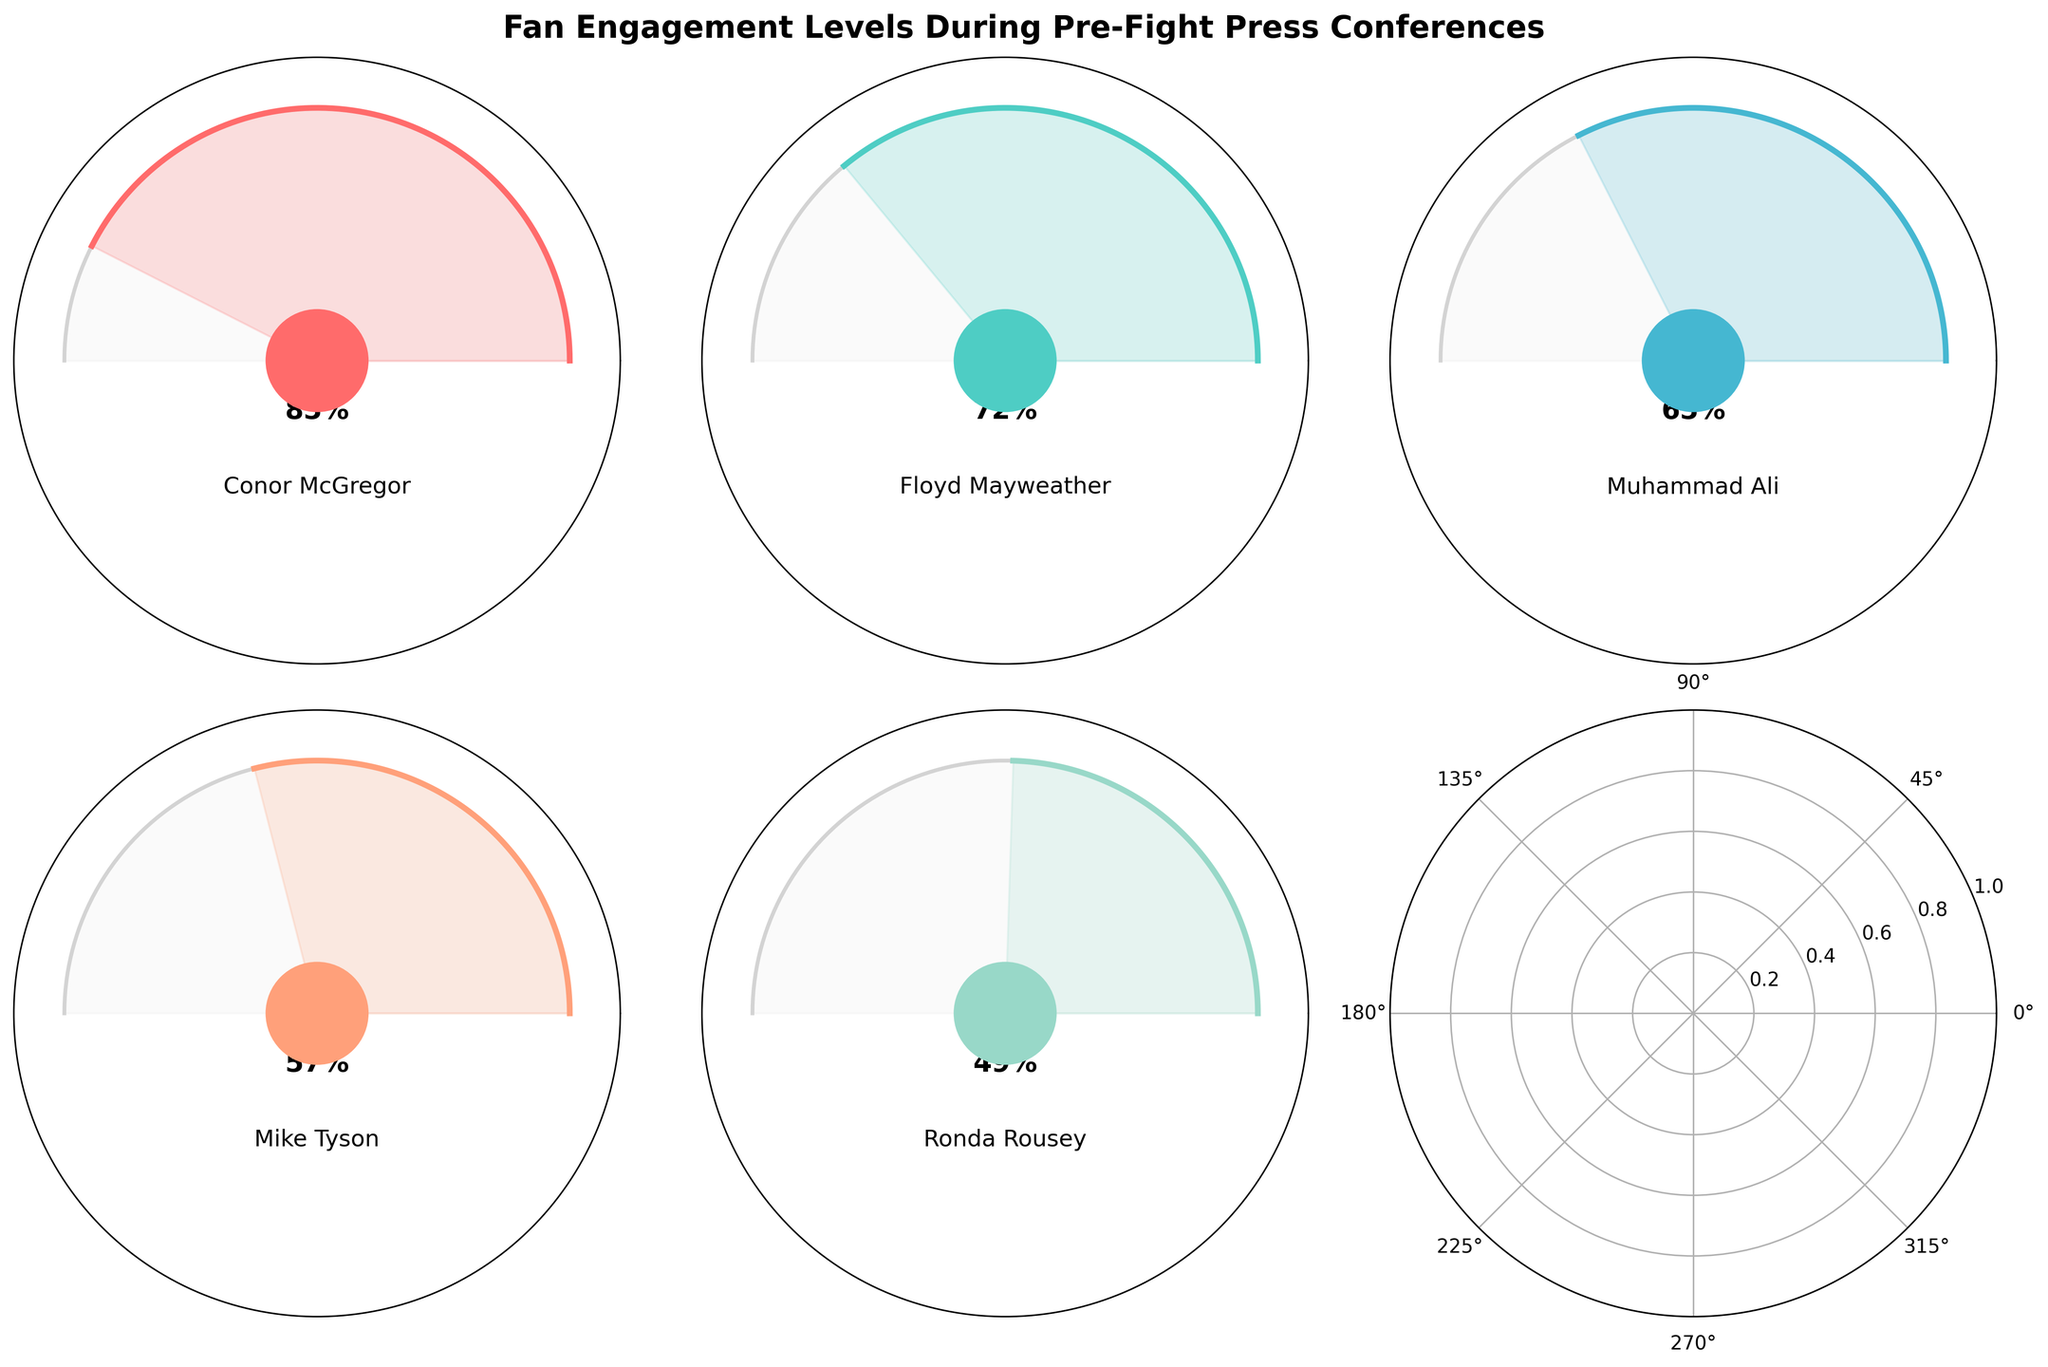who displays the highest fan engagement level during the pre-fight press conferences? Conor McGregor leads in fan engagement with 850,000 interactions. This is indicated by the gauge chart where his fan engagement level is the highest among all fighters.
Answer: Conor McGregor which fighter has the lowest fan engagement level? Ronda Rousey has the lowest fan engagement level with 490,000 social media interactions, as represented by the smallest filled portion in her gauge chart.
Answer: Ronda Rousey How many fighters have fan engagement levels above 700,000? Conor McGregor and Floyd Mayweather have fan engagement levels above 700,000. This can be observed from their respective gauge charts.
Answer: 2 Compare the fan engagement levels of Muhammad Ali and Mike Tyson. Who has higher engagement? Muhammad Ali has a higher engagement level (650,000) compared to Mike Tyson (580,000). This is shown by the larger filled portion in Muhammad Ali's gauge chart.
Answer: Muhammad Ali What is the combined fan engagement level of the fighters with the two highest interactions? Adding Conor McGregor's 850,000 interactions and Floyd Mayweather's 720,000 interactions gives a total of 1,570,000.
Answer: 1,570,000 What's the difference in fan engagement levels between the highest and lowest engaged fighters? The difference between the highest (Conor McGregor: 850,000) and the lowest (Ronda Rousey: 490,000) is 360,000 interactions.
Answer: 360,000 Are there any fighters with fan engagement levels close to the maximum possible interactions? Both Conor McGregor and Floyd Mayweather have fan engagement levels that are close to the maximum possible interactions (1,000,000), with 850,000 and 720,000 respectively.
Answer: Yes What percentage of maximum fan engagement does Mike Tyson achieve? Mike Tyson achieves 58% of the maximum fan engagement. This is evident from his gauge chart showing 580,000 interactions out of a possible 1,000,000.
Answer: 58% 